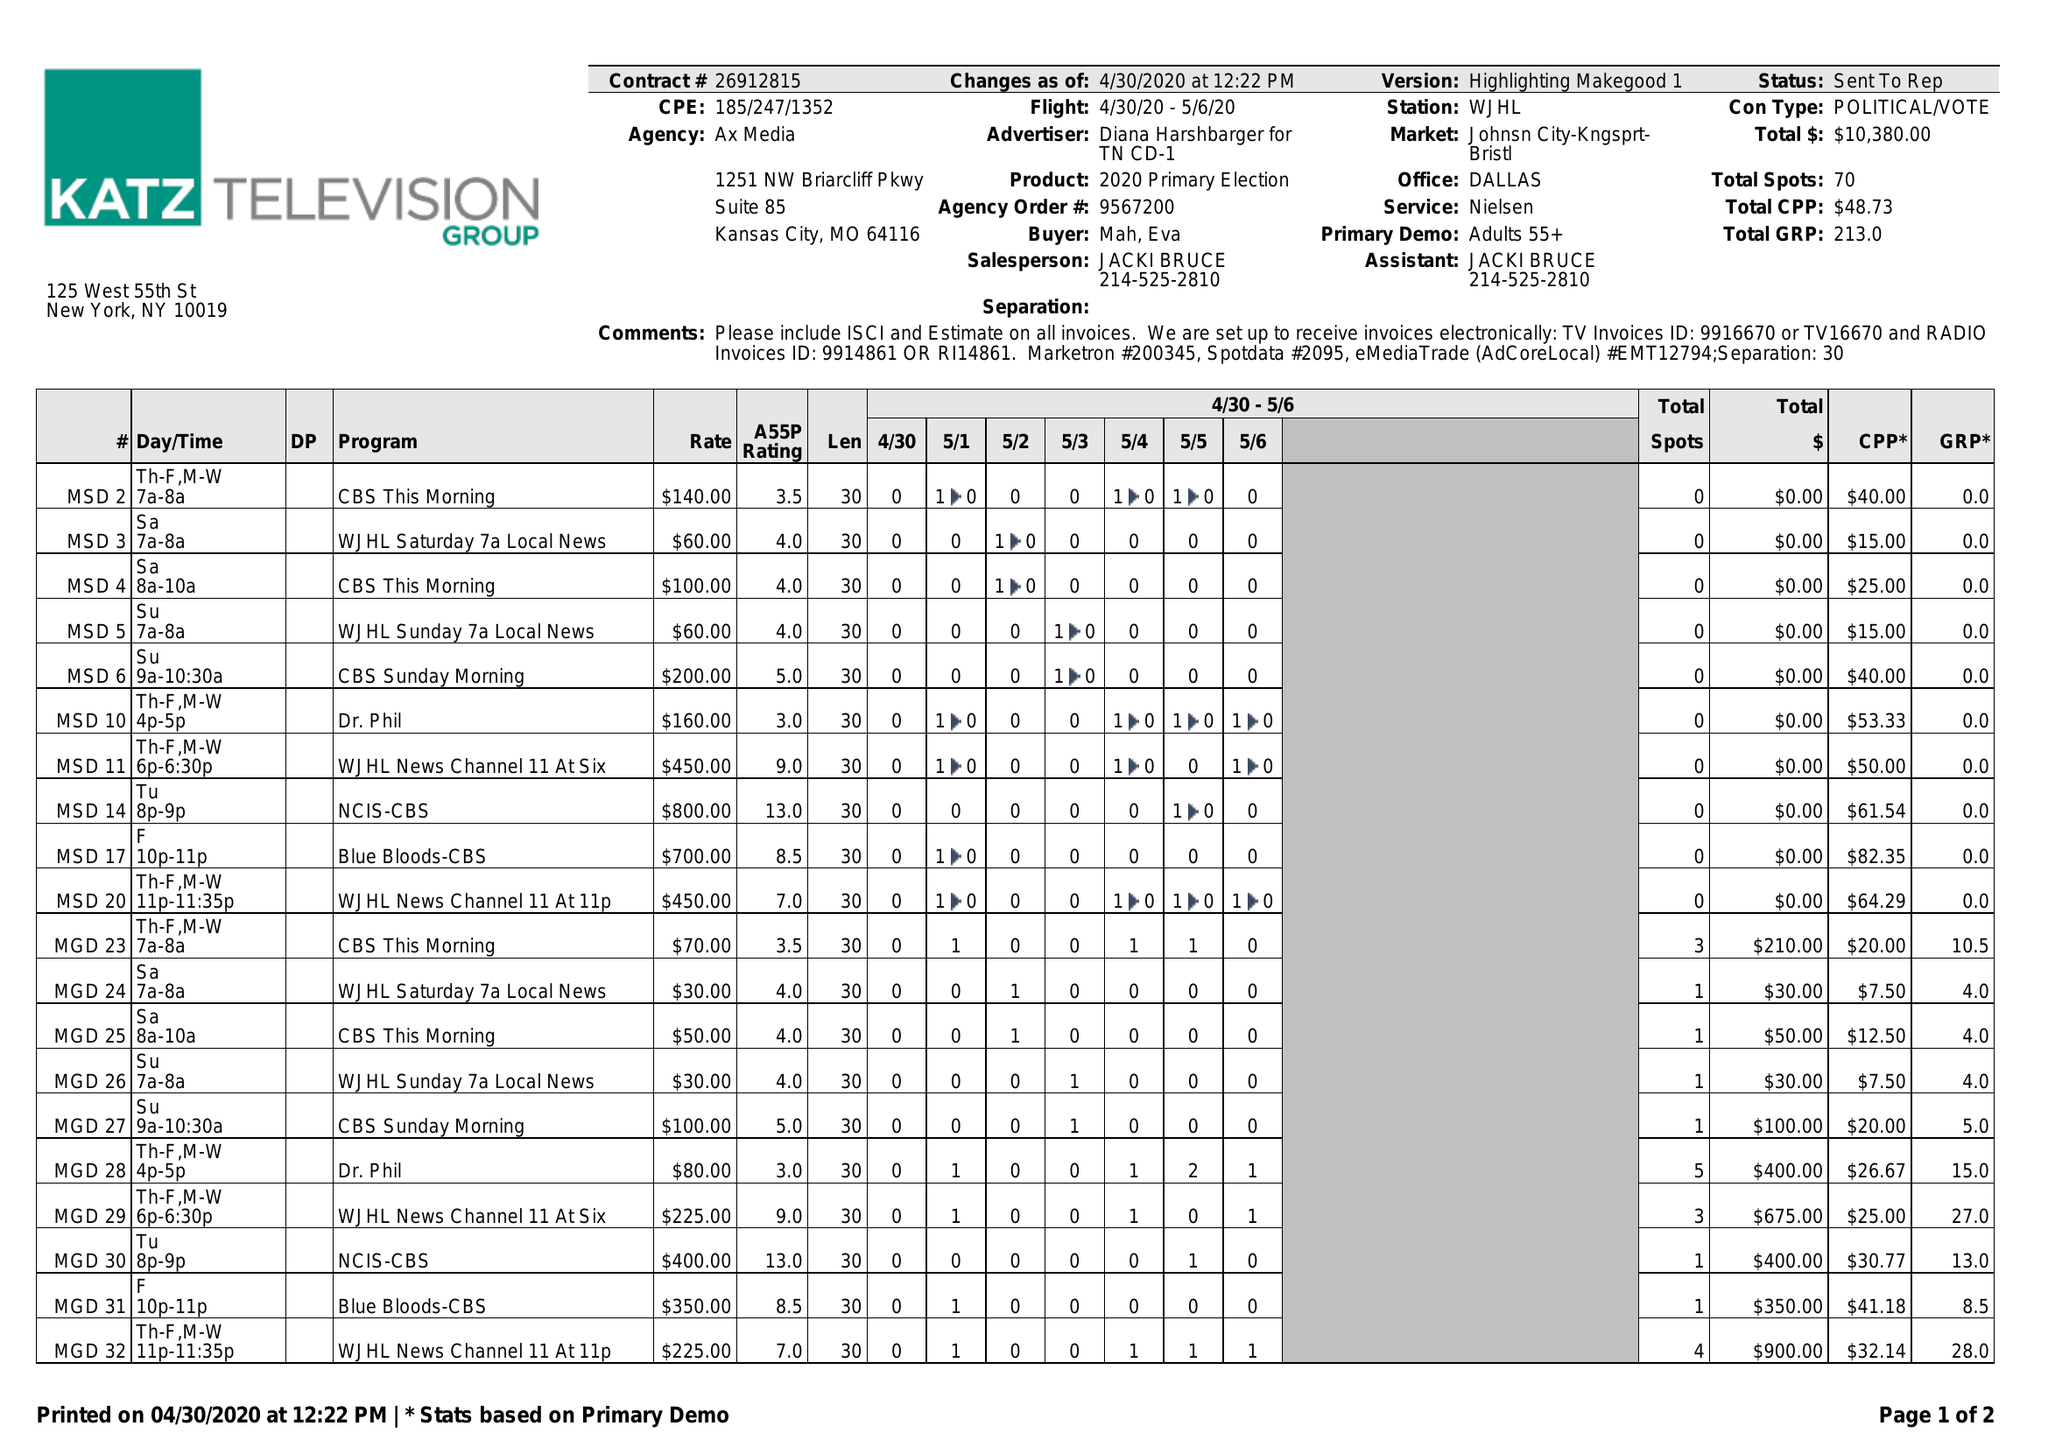What is the value for the contract_num?
Answer the question using a single word or phrase. 26912815 